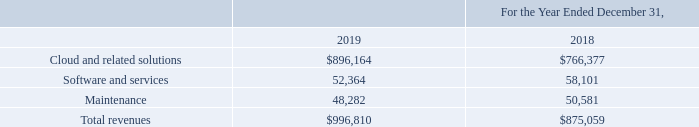Disaggregation of Revenues
The nature, amount, timing and uncertainty of our revenue and how revenue and cash flows are affected by economic factors is most appropriately depicted by type of revenue as presented below (in thousands) and by geographic region as presented in Note 3
What is a factor affecting the nature, amount, timing and uncertainty of the company's revenue? Maintenance. What is the amount of cash flow pertaining to maintenance in 2019?
Answer scale should be: thousand. 48,282. What is the amount of revenue earned by the company in 2019?
Answer scale should be: thousand. $996,810. What is the percentage change in revenue between 2018 and 2019?
Answer scale should be: percent. (996,810-875,059)/875,059
Answer: 13.91. What is the proportion of total revenue arising from cloud and related solutions in 2019?
Answer scale should be: percent. 896,164/996,810 
Answer: 89.9. What is the total revenue earned from 2018 to 2019?
Answer scale should be: thousand. $875,059+$996,810 
Answer: 1871869. 